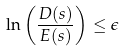<formula> <loc_0><loc_0><loc_500><loc_500>\ln \left ( \frac { D ( s ) } { E ( s ) } \right ) \leq \epsilon</formula> 